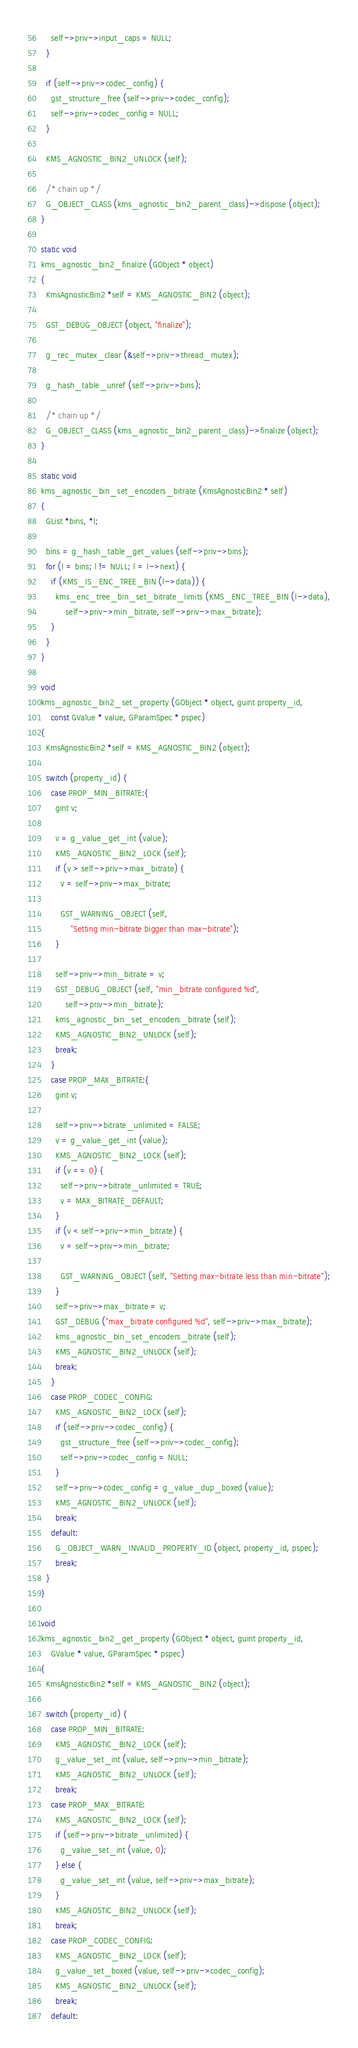Convert code to text. <code><loc_0><loc_0><loc_500><loc_500><_C_>    self->priv->input_caps = NULL;
  }

  if (self->priv->codec_config) {
    gst_structure_free (self->priv->codec_config);
    self->priv->codec_config = NULL;
  }

  KMS_AGNOSTIC_BIN2_UNLOCK (self);

  /* chain up */
  G_OBJECT_CLASS (kms_agnostic_bin2_parent_class)->dispose (object);
}

static void
kms_agnostic_bin2_finalize (GObject * object)
{
  KmsAgnosticBin2 *self = KMS_AGNOSTIC_BIN2 (object);

  GST_DEBUG_OBJECT (object, "finalize");

  g_rec_mutex_clear (&self->priv->thread_mutex);

  g_hash_table_unref (self->priv->bins);

  /* chain up */
  G_OBJECT_CLASS (kms_agnostic_bin2_parent_class)->finalize (object);
}

static void
kms_agnostic_bin_set_encoders_bitrate (KmsAgnosticBin2 * self)
{
  GList *bins, *l;

  bins = g_hash_table_get_values (self->priv->bins);
  for (l = bins; l != NULL; l = l->next) {
    if (KMS_IS_ENC_TREE_BIN (l->data)) {
      kms_enc_tree_bin_set_bitrate_limits (KMS_ENC_TREE_BIN (l->data),
          self->priv->min_bitrate, self->priv->max_bitrate);
    }
  }
}

void
kms_agnostic_bin2_set_property (GObject * object, guint property_id,
    const GValue * value, GParamSpec * pspec)
{
  KmsAgnosticBin2 *self = KMS_AGNOSTIC_BIN2 (object);

  switch (property_id) {
    case PROP_MIN_BITRATE:{
      gint v;

      v = g_value_get_int (value);
      KMS_AGNOSTIC_BIN2_LOCK (self);
      if (v > self->priv->max_bitrate) {
        v = self->priv->max_bitrate;

        GST_WARNING_OBJECT (self,
            "Setting min-bitrate bigger than max-bitrate");
      }

      self->priv->min_bitrate = v;
      GST_DEBUG_OBJECT (self, "min_bitrate configured %d",
          self->priv->min_bitrate);
      kms_agnostic_bin_set_encoders_bitrate (self);
      KMS_AGNOSTIC_BIN2_UNLOCK (self);
      break;
    }
    case PROP_MAX_BITRATE:{
      gint v;

      self->priv->bitrate_unlimited = FALSE;
      v = g_value_get_int (value);
      KMS_AGNOSTIC_BIN2_LOCK (self);
      if (v == 0) {
        self->priv->bitrate_unlimited = TRUE;
        v = MAX_BITRATE_DEFAULT;
      }
      if (v < self->priv->min_bitrate) {
        v = self->priv->min_bitrate;

        GST_WARNING_OBJECT (self, "Setting max-bitrate less than min-bitrate");
      }
      self->priv->max_bitrate = v;
      GST_DEBUG ("max_bitrate configured %d", self->priv->max_bitrate);
      kms_agnostic_bin_set_encoders_bitrate (self);
      KMS_AGNOSTIC_BIN2_UNLOCK (self);
      break;
    }
    case PROP_CODEC_CONFIG:
      KMS_AGNOSTIC_BIN2_LOCK (self);
      if (self->priv->codec_config) {
        gst_structure_free (self->priv->codec_config);
        self->priv->codec_config = NULL;
      }
      self->priv->codec_config = g_value_dup_boxed (value);
      KMS_AGNOSTIC_BIN2_UNLOCK (self);
      break;
    default:
      G_OBJECT_WARN_INVALID_PROPERTY_ID (object, property_id, pspec);
      break;
  }
}

void
kms_agnostic_bin2_get_property (GObject * object, guint property_id,
    GValue * value, GParamSpec * pspec)
{
  KmsAgnosticBin2 *self = KMS_AGNOSTIC_BIN2 (object);

  switch (property_id) {
    case PROP_MIN_BITRATE:
      KMS_AGNOSTIC_BIN2_LOCK (self);
      g_value_set_int (value, self->priv->min_bitrate);
      KMS_AGNOSTIC_BIN2_UNLOCK (self);
      break;
    case PROP_MAX_BITRATE:
      KMS_AGNOSTIC_BIN2_LOCK (self);
      if (self->priv->bitrate_unlimited) {
        g_value_set_int (value, 0);
      } else {
        g_value_set_int (value, self->priv->max_bitrate);
      }
      KMS_AGNOSTIC_BIN2_UNLOCK (self);
      break;
    case PROP_CODEC_CONFIG:
      KMS_AGNOSTIC_BIN2_LOCK (self);
      g_value_set_boxed (value, self->priv->codec_config);
      KMS_AGNOSTIC_BIN2_UNLOCK (self);
      break;
    default:</code> 